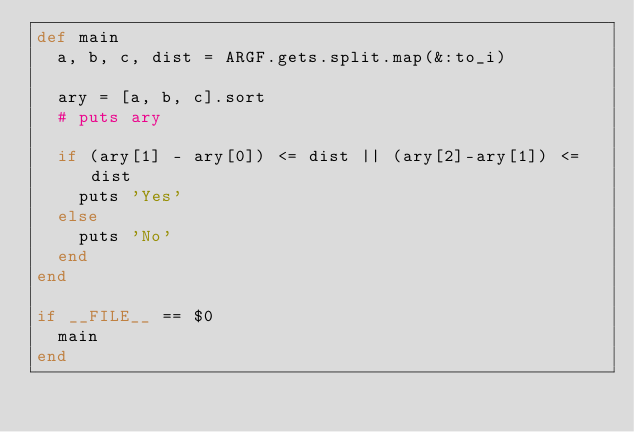<code> <loc_0><loc_0><loc_500><loc_500><_Ruby_>def main
  a, b, c, dist = ARGF.gets.split.map(&:to_i)

  ary = [a, b, c].sort
  # puts ary

  if (ary[1] - ary[0]) <= dist || (ary[2]-ary[1]) <= dist
    puts 'Yes'
  else
    puts 'No'
  end
end

if __FILE__ == $0
  main
end
</code> 